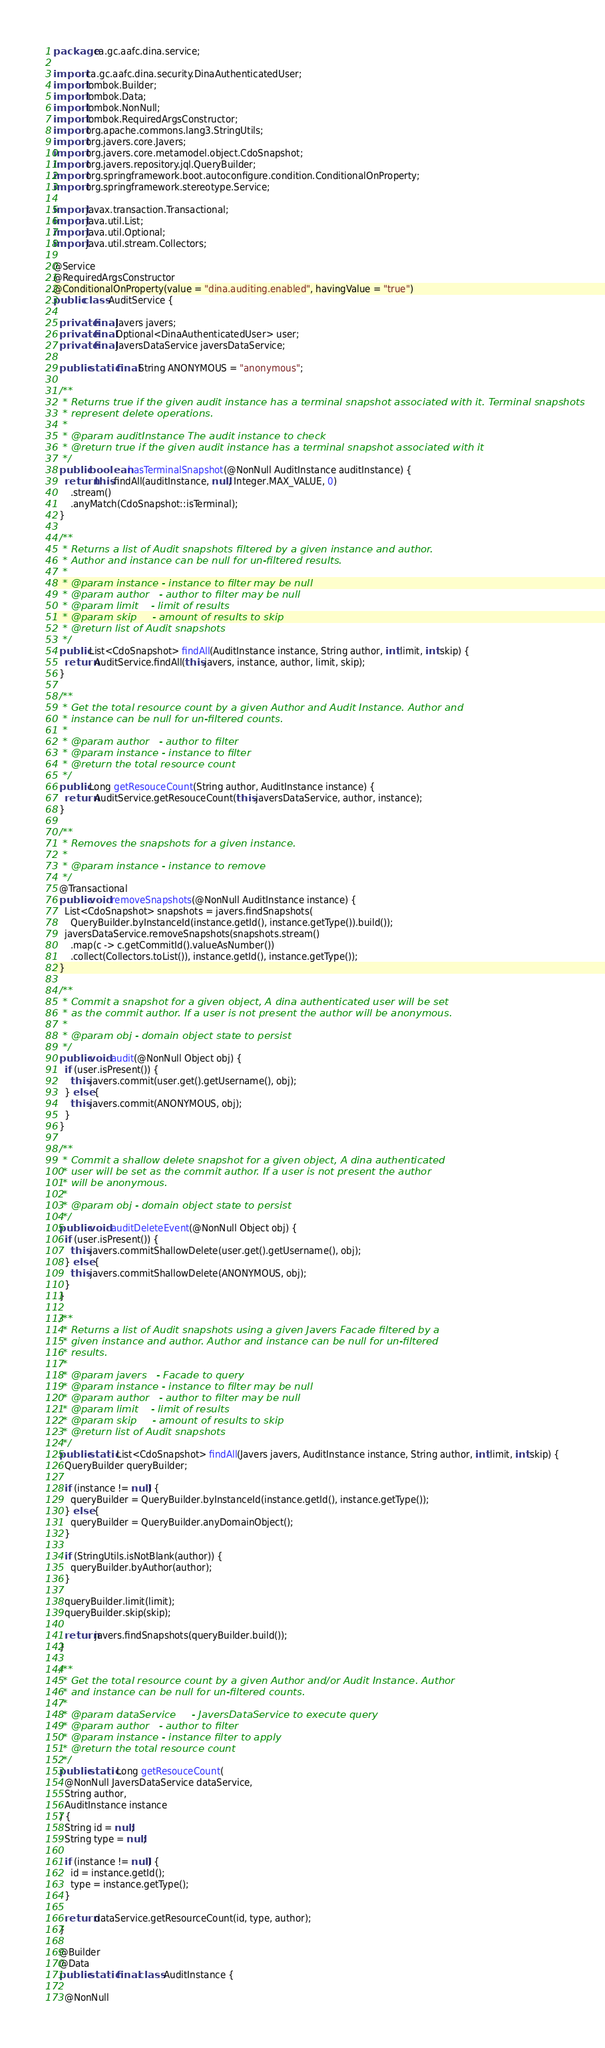<code> <loc_0><loc_0><loc_500><loc_500><_Java_>package ca.gc.aafc.dina.service;

import ca.gc.aafc.dina.security.DinaAuthenticatedUser;
import lombok.Builder;
import lombok.Data;
import lombok.NonNull;
import lombok.RequiredArgsConstructor;
import org.apache.commons.lang3.StringUtils;
import org.javers.core.Javers;
import org.javers.core.metamodel.object.CdoSnapshot;
import org.javers.repository.jql.QueryBuilder;
import org.springframework.boot.autoconfigure.condition.ConditionalOnProperty;
import org.springframework.stereotype.Service;

import javax.transaction.Transactional;
import java.util.List;
import java.util.Optional;
import java.util.stream.Collectors;

@Service
@RequiredArgsConstructor
@ConditionalOnProperty(value = "dina.auditing.enabled", havingValue = "true")
public class AuditService {

  private final Javers javers;
  private final Optional<DinaAuthenticatedUser> user;
  private final JaversDataService javersDataService;

  public static final String ANONYMOUS = "anonymous";

  /**
   * Returns true if the given audit instance has a terminal snapshot associated with it. Terminal snapshots
   * represent delete operations.
   *
   * @param auditInstance The audit instance to check
   * @return true if the given audit instance has a terminal snapshot associated with it
   */
  public boolean hasTerminalSnapshot(@NonNull AuditInstance auditInstance) {
    return this.findAll(auditInstance, null, Integer.MAX_VALUE, 0)
      .stream()
      .anyMatch(CdoSnapshot::isTerminal);
  }

  /**
   * Returns a list of Audit snapshots filtered by a given instance and author.
   * Author and instance can be null for un-filtered results.
   *
   * @param instance - instance to filter may be null
   * @param author   - author to filter may be null
   * @param limit    - limit of results
   * @param skip     - amount of results to skip
   * @return list of Audit snapshots
   */
  public List<CdoSnapshot> findAll(AuditInstance instance, String author, int limit, int skip) {
    return AuditService.findAll(this.javers, instance, author, limit, skip);
  }

  /**
   * Get the total resource count by a given Author and Audit Instance. Author and
   * instance can be null for un-filtered counts.
   *
   * @param author   - author to filter
   * @param instance - instance to filter
   * @return the total resource count
   */
  public Long getResouceCount(String author, AuditInstance instance) {
    return AuditService.getResouceCount(this.javersDataService, author, instance);
  }

  /**
   * Removes the snapshots for a given instance.
   *
   * @param instance - instance to remove
   */
  @Transactional
  public void removeSnapshots(@NonNull AuditInstance instance) {
    List<CdoSnapshot> snapshots = javers.findSnapshots(
      QueryBuilder.byInstanceId(instance.getId(), instance.getType()).build());
    javersDataService.removeSnapshots(snapshots.stream()
      .map(c -> c.getCommitId().valueAsNumber())
      .collect(Collectors.toList()), instance.getId(), instance.getType());
  }

  /**
   * Commit a snapshot for a given object, A dina authenticated user will be set
   * as the commit author. If a user is not present the author will be anonymous.
   *
   * @param obj - domain object state to persist
   */
  public void audit(@NonNull Object obj) {
    if (user.isPresent()) {
      this.javers.commit(user.get().getUsername(), obj);
    } else {
      this.javers.commit(ANONYMOUS, obj);
    }
  }

  /**
   * Commit a shallow delete snapshot for a given object, A dina authenticated
   * user will be set as the commit author. If a user is not present the author
   * will be anonymous.
   *
   * @param obj - domain object state to persist
   */
  public void auditDeleteEvent(@NonNull Object obj) {
    if (user.isPresent()) {
      this.javers.commitShallowDelete(user.get().getUsername(), obj);
    } else {
      this.javers.commitShallowDelete(ANONYMOUS, obj);
    }
  }

  /**
   * Returns a list of Audit snapshots using a given Javers Facade filtered by a
   * given instance and author. Author and instance can be null for un-filtered
   * results.
   *
   * @param javers   - Facade to query
   * @param instance - instance to filter may be null
   * @param author   - author to filter may be null
   * @param limit    - limit of results
   * @param skip     - amount of results to skip
   * @return list of Audit snapshots
   */
  public static List<CdoSnapshot> findAll(Javers javers, AuditInstance instance, String author, int limit, int skip) {
    QueryBuilder queryBuilder;

    if (instance != null) {
      queryBuilder = QueryBuilder.byInstanceId(instance.getId(), instance.getType());
    } else {
      queryBuilder = QueryBuilder.anyDomainObject();
    }

    if (StringUtils.isNotBlank(author)) {
      queryBuilder.byAuthor(author);
    }

    queryBuilder.limit(limit);
    queryBuilder.skip(skip);

    return javers.findSnapshots(queryBuilder.build());
  }

  /**
   * Get the total resource count by a given Author and/or Audit Instance. Author
   * and instance can be null for un-filtered counts.
   *
   * @param dataService     - JaversDataService to execute query
   * @param author   - author to filter
   * @param instance - instance filter to apply
   * @return the total resource count
   */
  public static Long getResouceCount(
    @NonNull JaversDataService dataService,
    String author,
    AuditInstance instance
  ) {
    String id = null;
    String type = null;

    if (instance != null) {
      id = instance.getId();
      type = instance.getType();
    }

    return dataService.getResourceCount(id, type, author);
  }

  @Builder
  @Data
  public static final class AuditInstance {

    @NonNull</code> 